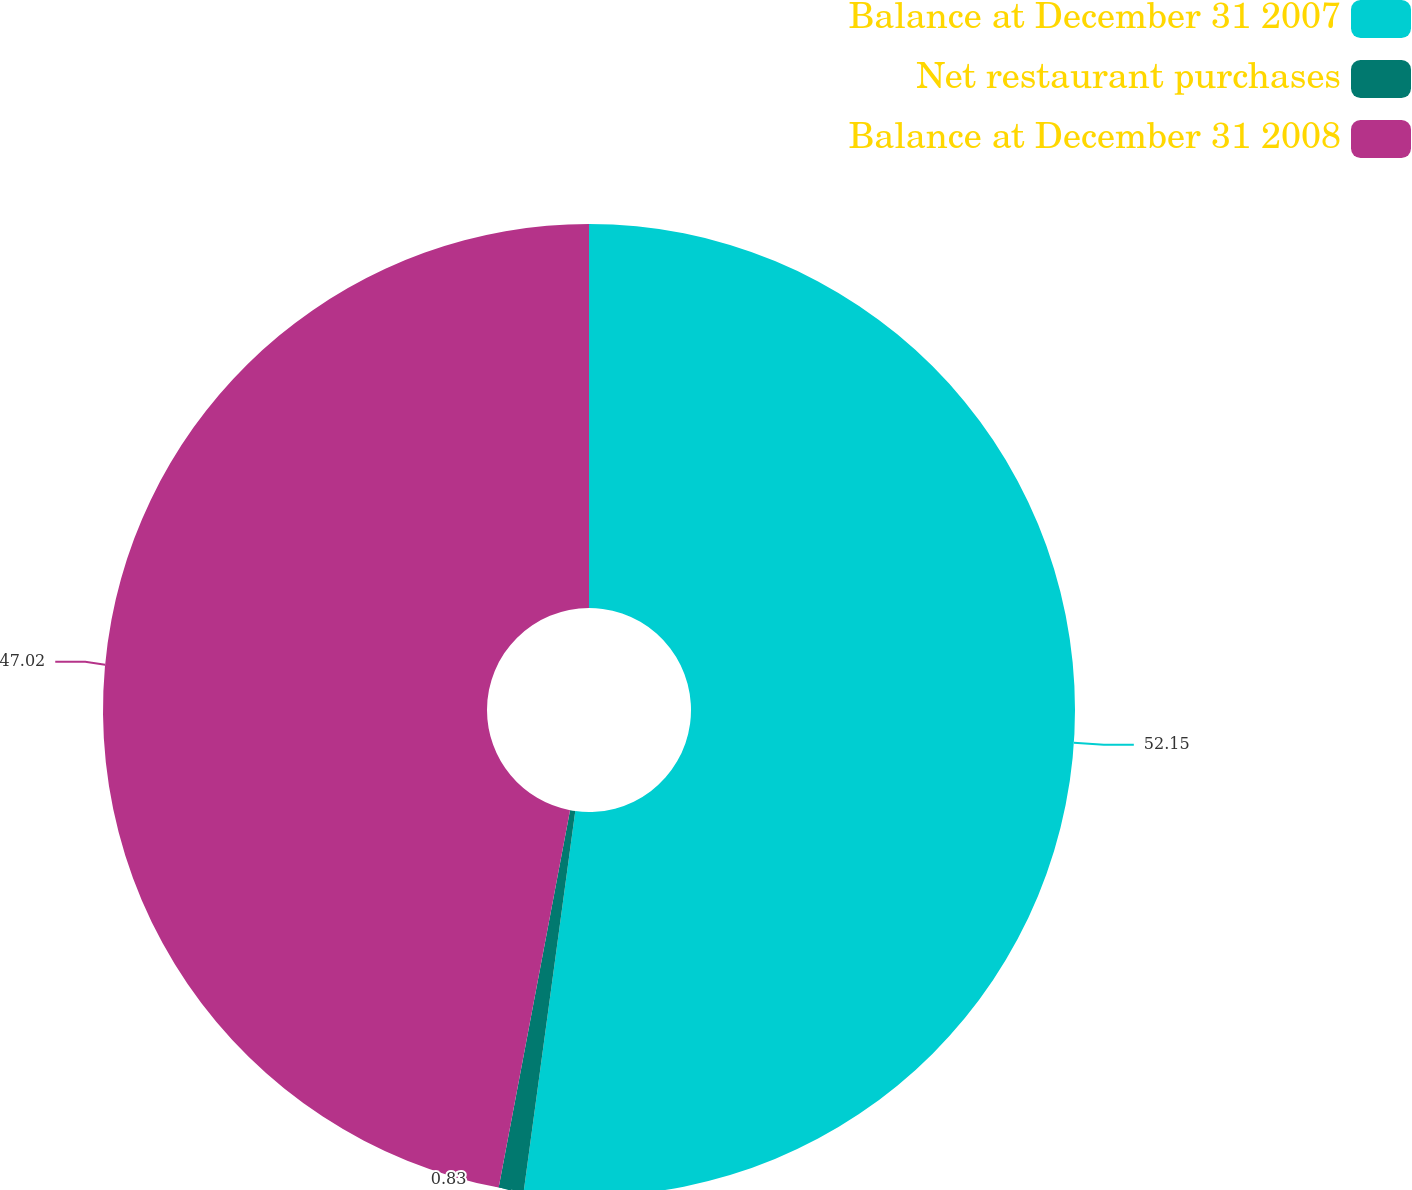Convert chart to OTSL. <chart><loc_0><loc_0><loc_500><loc_500><pie_chart><fcel>Balance at December 31 2007<fcel>Net restaurant purchases<fcel>Balance at December 31 2008<nl><fcel>52.14%<fcel>0.83%<fcel>47.02%<nl></chart> 